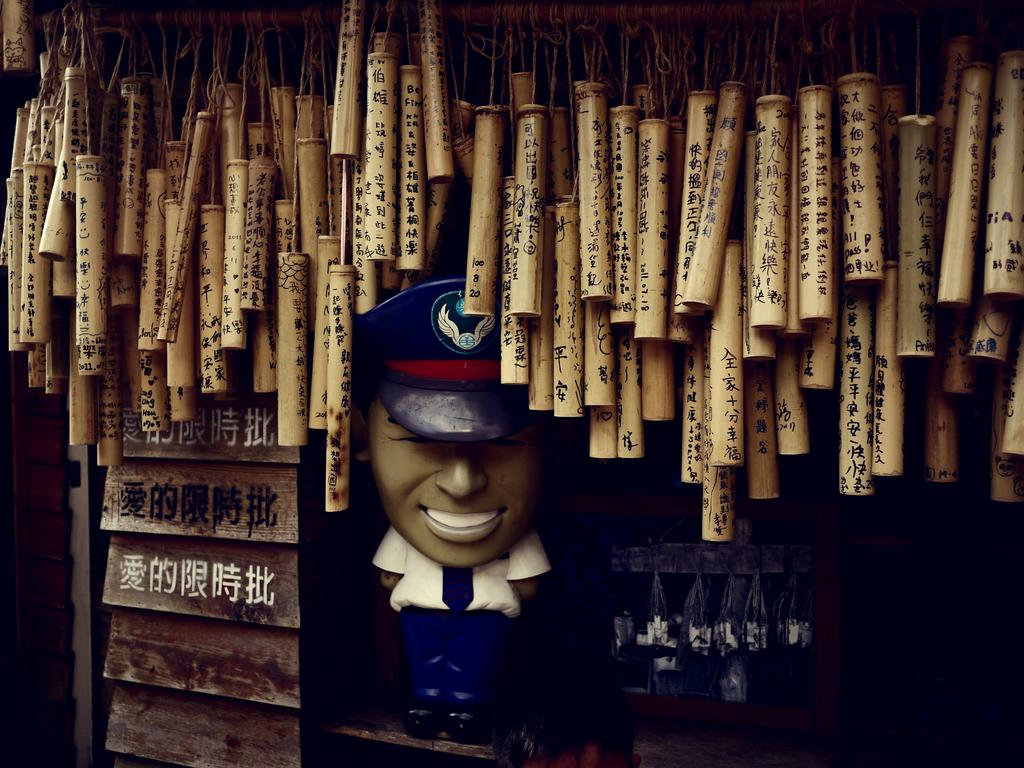<image>
Give a short and clear explanation of the subsequent image. Many windchimes hang from the ceiling, and the second one from the right has the letter "A" on it. 